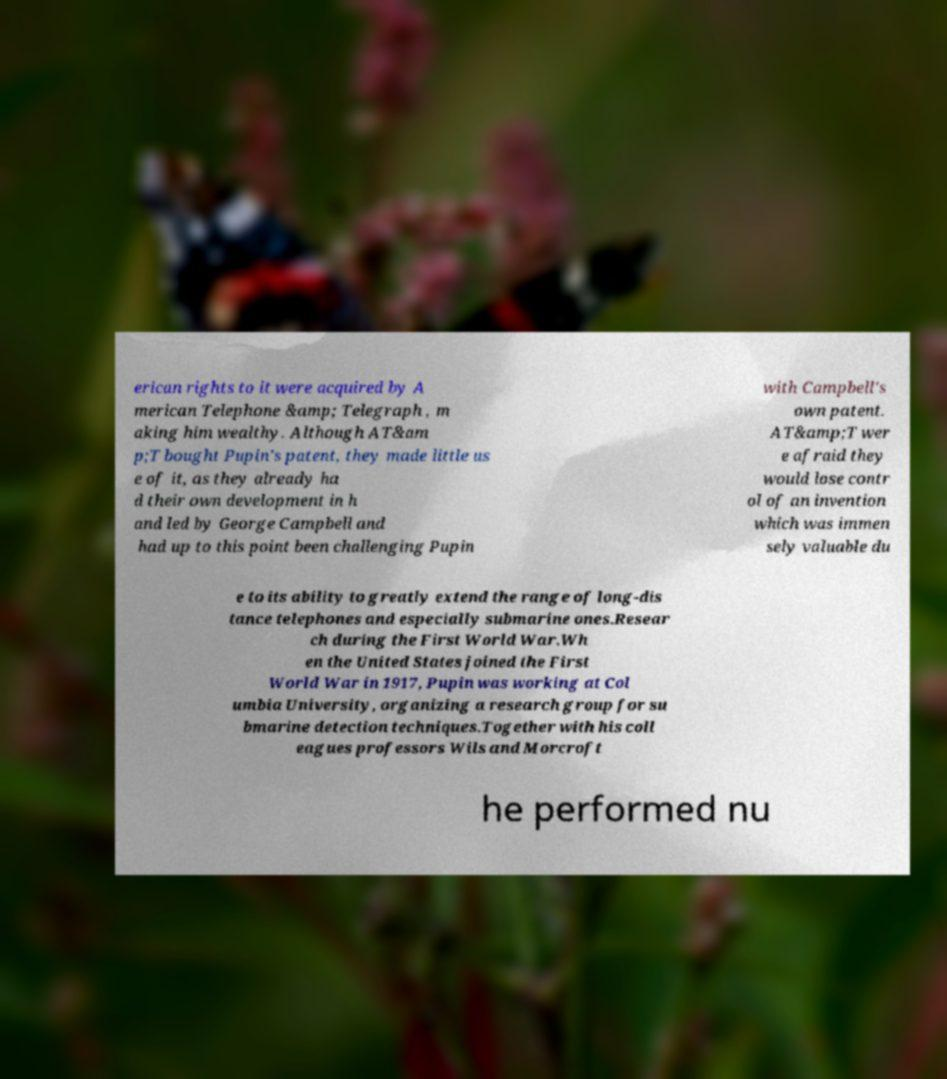Can you read and provide the text displayed in the image?This photo seems to have some interesting text. Can you extract and type it out for me? erican rights to it were acquired by A merican Telephone &amp; Telegraph , m aking him wealthy. Although AT&am p;T bought Pupin's patent, they made little us e of it, as they already ha d their own development in h and led by George Campbell and had up to this point been challenging Pupin with Campbell's own patent. AT&amp;T wer e afraid they would lose contr ol of an invention which was immen sely valuable du e to its ability to greatly extend the range of long-dis tance telephones and especially submarine ones.Resear ch during the First World War.Wh en the United States joined the First World War in 1917, Pupin was working at Col umbia University, organizing a research group for su bmarine detection techniques.Together with his coll eagues professors Wils and Morcroft he performed nu 